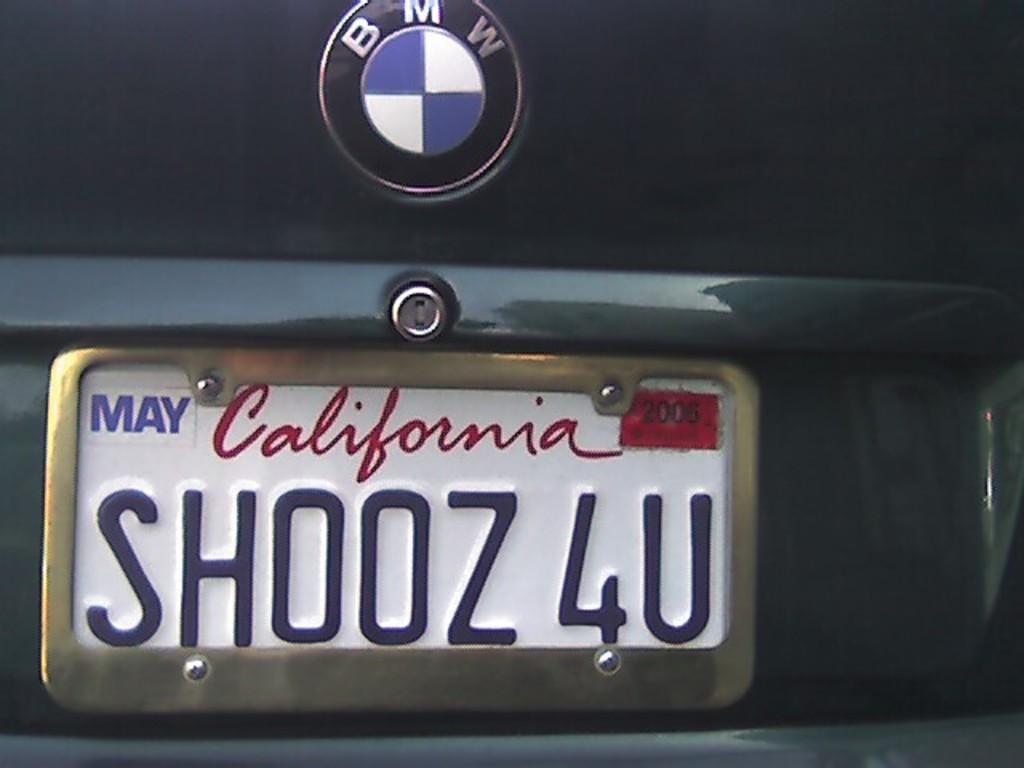<image>
Give a short and clear explanation of the subsequent image. A BMW has a California license plate that reads SHOOZ 4U. 